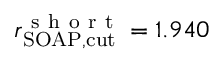<formula> <loc_0><loc_0><loc_500><loc_500>r _ { S O A P , c u t } ^ { s h o r t } = 1 . 9 4 0</formula> 